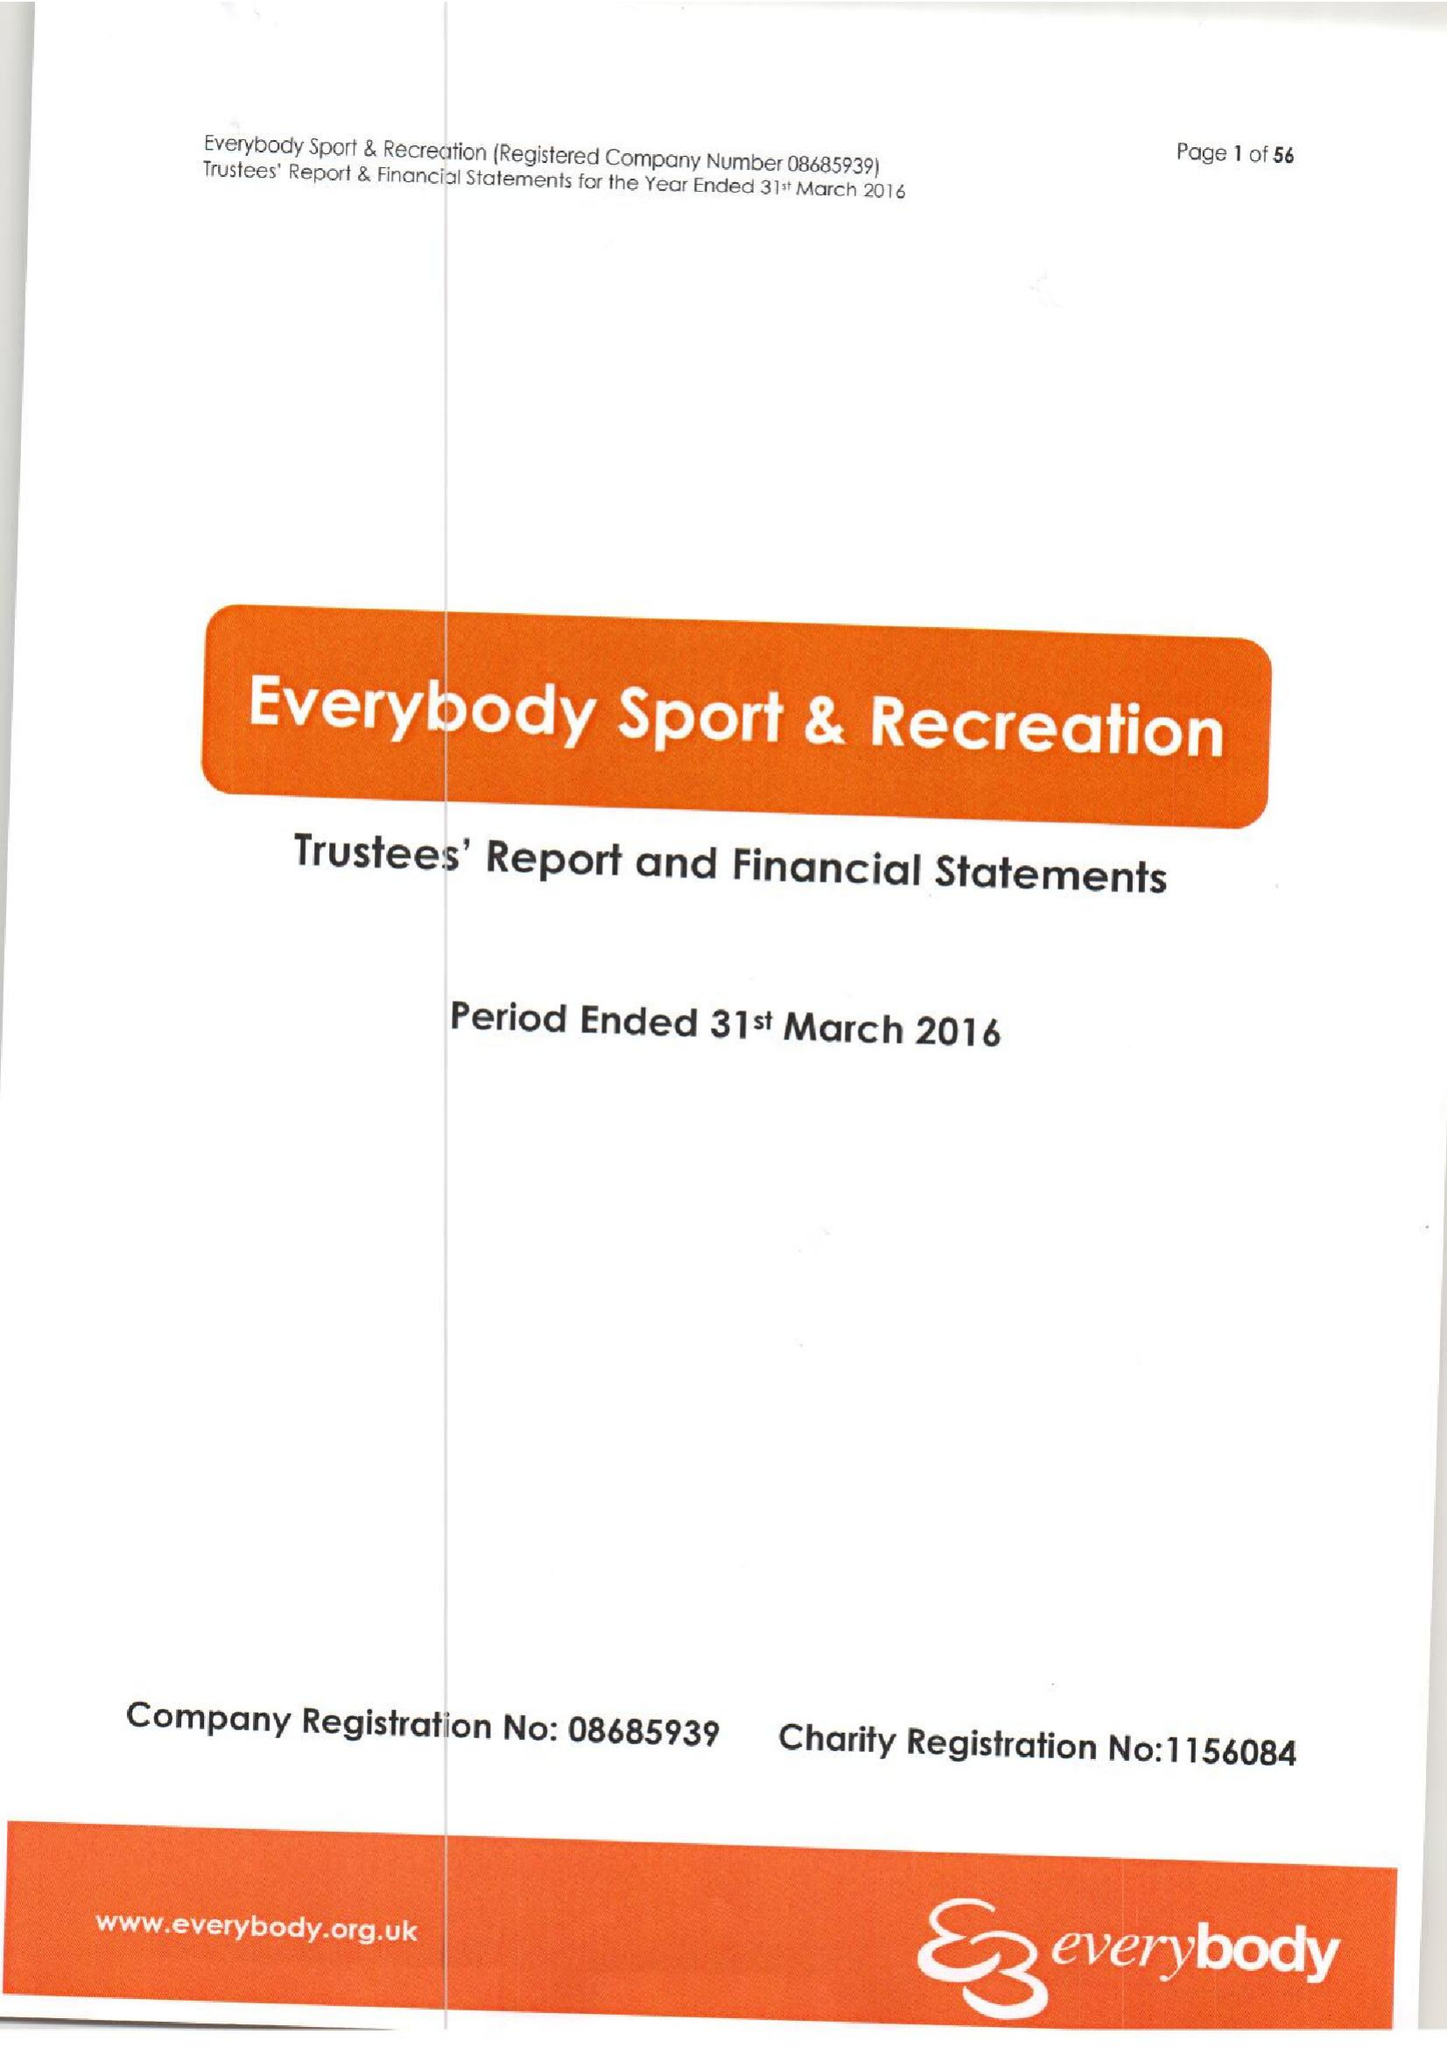What is the value for the spending_annually_in_british_pounds?
Answer the question using a single word or phrase. 14134513.00 